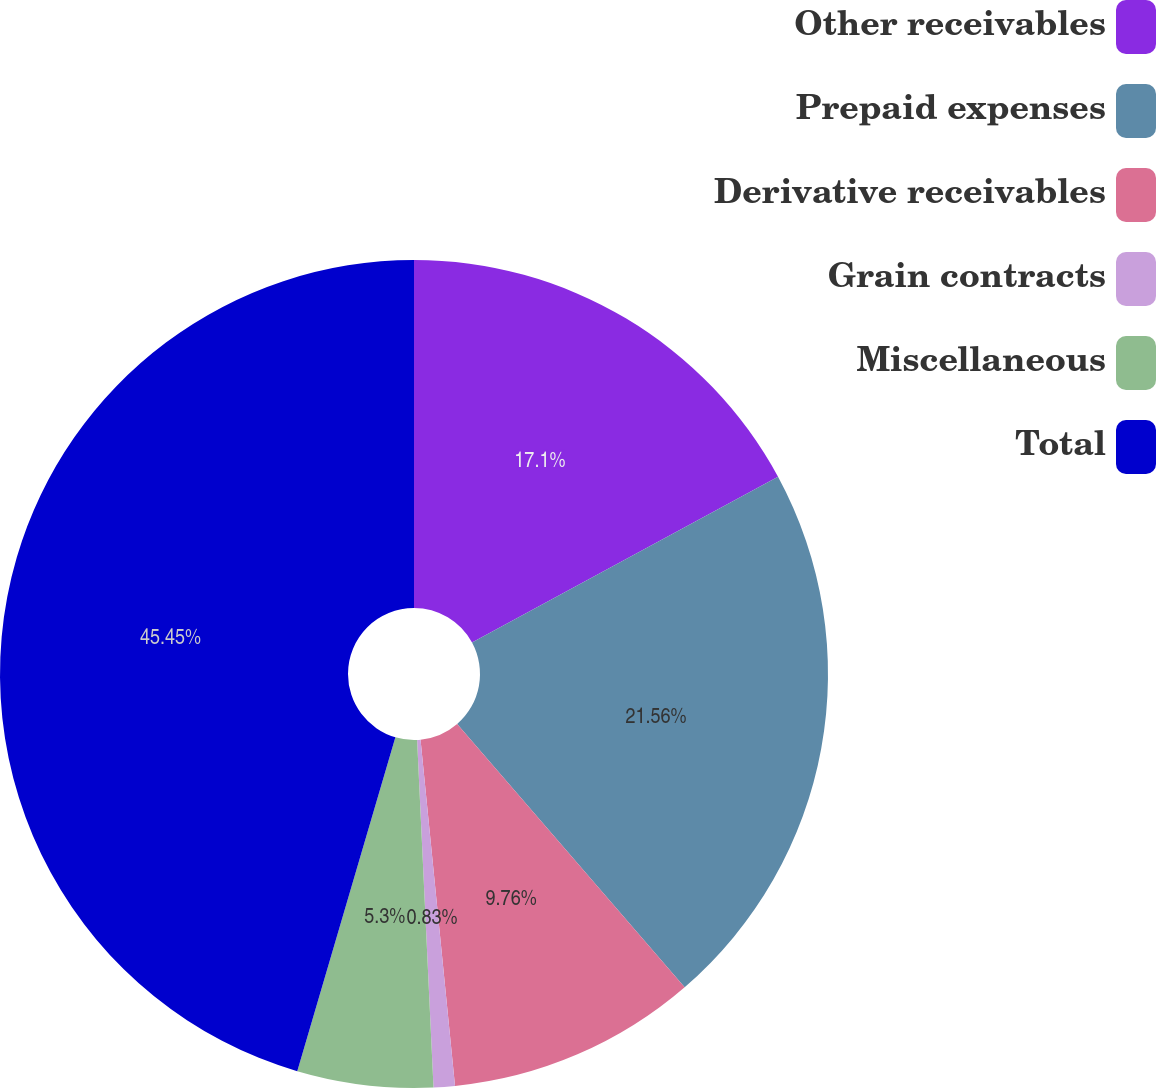<chart> <loc_0><loc_0><loc_500><loc_500><pie_chart><fcel>Other receivables<fcel>Prepaid expenses<fcel>Derivative receivables<fcel>Grain contracts<fcel>Miscellaneous<fcel>Total<nl><fcel>17.1%<fcel>21.56%<fcel>9.76%<fcel>0.83%<fcel>5.3%<fcel>45.45%<nl></chart> 